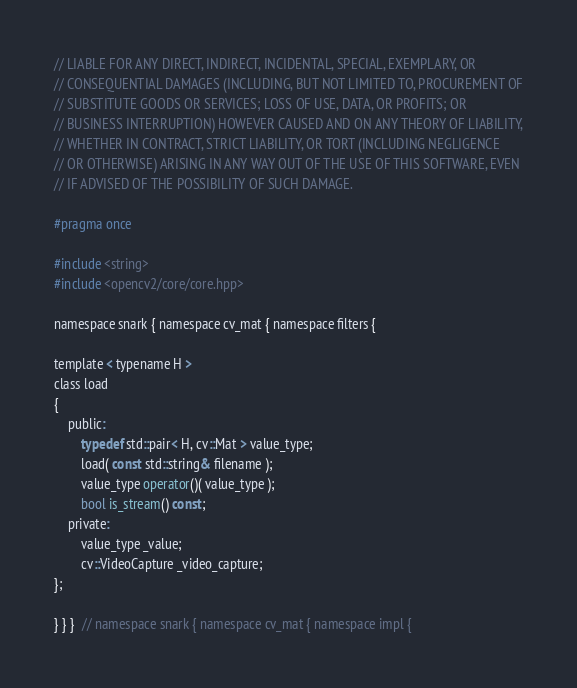Convert code to text. <code><loc_0><loc_0><loc_500><loc_500><_C_>// LIABLE FOR ANY DIRECT, INDIRECT, INCIDENTAL, SPECIAL, EXEMPLARY, OR
// CONSEQUENTIAL DAMAGES (INCLUDING, BUT NOT LIMITED TO, PROCUREMENT OF
// SUBSTITUTE GOODS OR SERVICES; LOSS OF USE, DATA, OR PROFITS; OR
// BUSINESS INTERRUPTION) HOWEVER CAUSED AND ON ANY THEORY OF LIABILITY,
// WHETHER IN CONTRACT, STRICT LIABILITY, OR TORT (INCLUDING NEGLIGENCE
// OR OTHERWISE) ARISING IN ANY WAY OUT OF THE USE OF THIS SOFTWARE, EVEN
// IF ADVISED OF THE POSSIBILITY OF SUCH DAMAGE.

#pragma once

#include <string>
#include <opencv2/core/core.hpp>

namespace snark { namespace cv_mat { namespace filters {

template < typename H >
class load
{
    public:
        typedef std::pair< H, cv::Mat > value_type;
        load( const std::string& filename );
        value_type operator()( value_type );
        bool is_stream() const;
    private:
        value_type _value;
        cv::VideoCapture _video_capture;
};

} } }  // namespace snark { namespace cv_mat { namespace impl {
</code> 